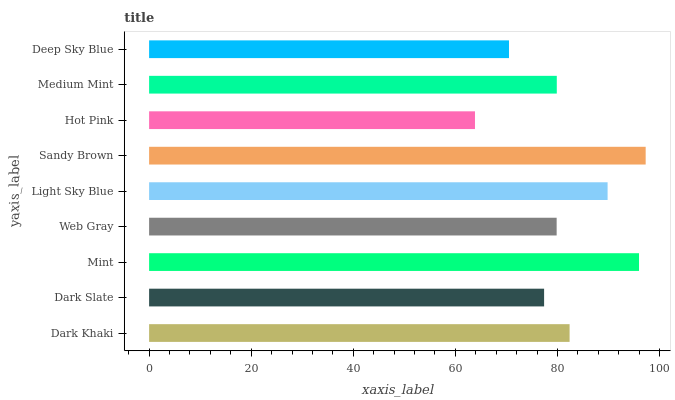Is Hot Pink the minimum?
Answer yes or no. Yes. Is Sandy Brown the maximum?
Answer yes or no. Yes. Is Dark Slate the minimum?
Answer yes or no. No. Is Dark Slate the maximum?
Answer yes or no. No. Is Dark Khaki greater than Dark Slate?
Answer yes or no. Yes. Is Dark Slate less than Dark Khaki?
Answer yes or no. Yes. Is Dark Slate greater than Dark Khaki?
Answer yes or no. No. Is Dark Khaki less than Dark Slate?
Answer yes or no. No. Is Medium Mint the high median?
Answer yes or no. Yes. Is Medium Mint the low median?
Answer yes or no. Yes. Is Hot Pink the high median?
Answer yes or no. No. Is Deep Sky Blue the low median?
Answer yes or no. No. 